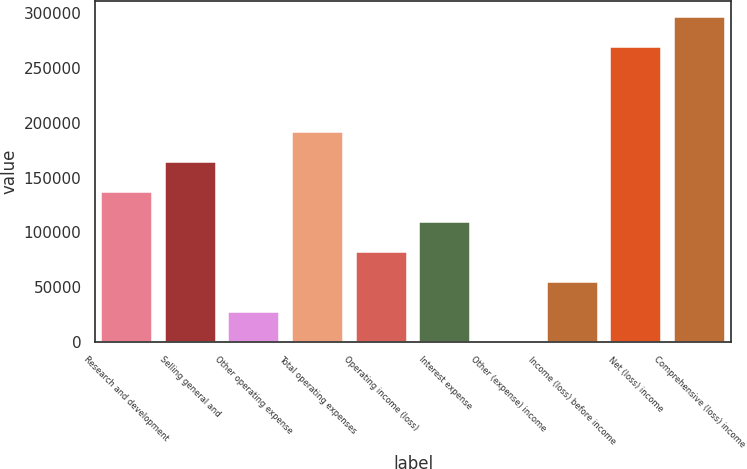Convert chart to OTSL. <chart><loc_0><loc_0><loc_500><loc_500><bar_chart><fcel>Research and development<fcel>Selling general and<fcel>Other operating expense<fcel>Total operating expenses<fcel>Operating income (loss)<fcel>Interest expense<fcel>Other (expense) income<fcel>Income (loss) before income<fcel>Net (loss) income<fcel>Comprehensive (loss) income<nl><fcel>136917<fcel>164299<fcel>27389.8<fcel>191681<fcel>82153.4<fcel>109535<fcel>8<fcel>54771.6<fcel>268950<fcel>296332<nl></chart> 